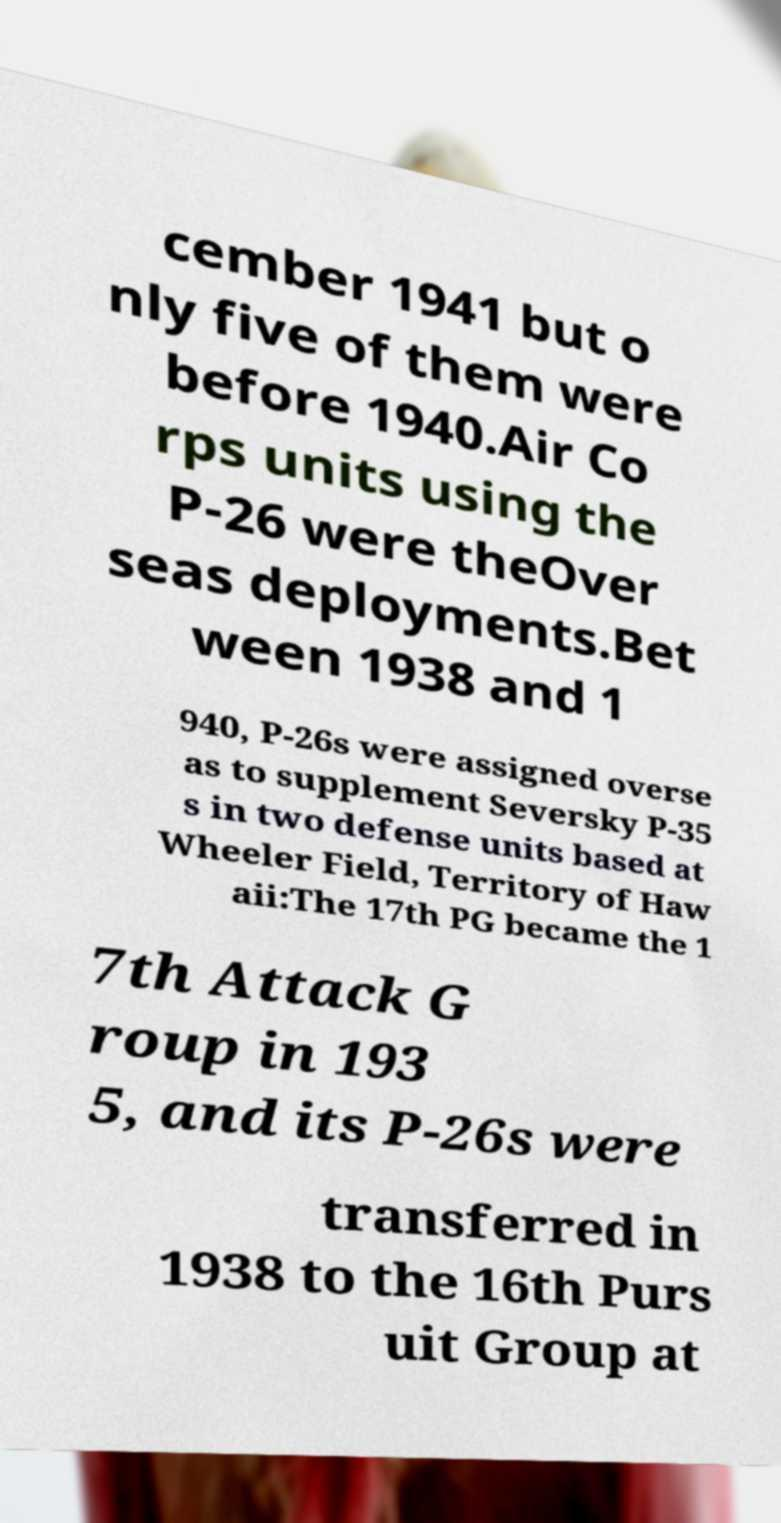Can you read and provide the text displayed in the image?This photo seems to have some interesting text. Can you extract and type it out for me? cember 1941 but o nly five of them were before 1940.Air Co rps units using the P-26 were theOver seas deployments.Bet ween 1938 and 1 940, P-26s were assigned overse as to supplement Seversky P-35 s in two defense units based at Wheeler Field, Territory of Haw aii:The 17th PG became the 1 7th Attack G roup in 193 5, and its P-26s were transferred in 1938 to the 16th Purs uit Group at 